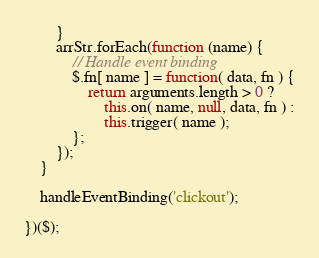<code> <loc_0><loc_0><loc_500><loc_500><_JavaScript_>		}
		arrStr.forEach(function (name) {
			// Handle event binding
			$.fn[ name ] = function( data, fn ) {
				return arguments.length > 0 ?
					this.on( name, null, data, fn ) :
					this.trigger( name );
			};
		});
	}

	handleEventBinding('clickout');

})($);</code> 